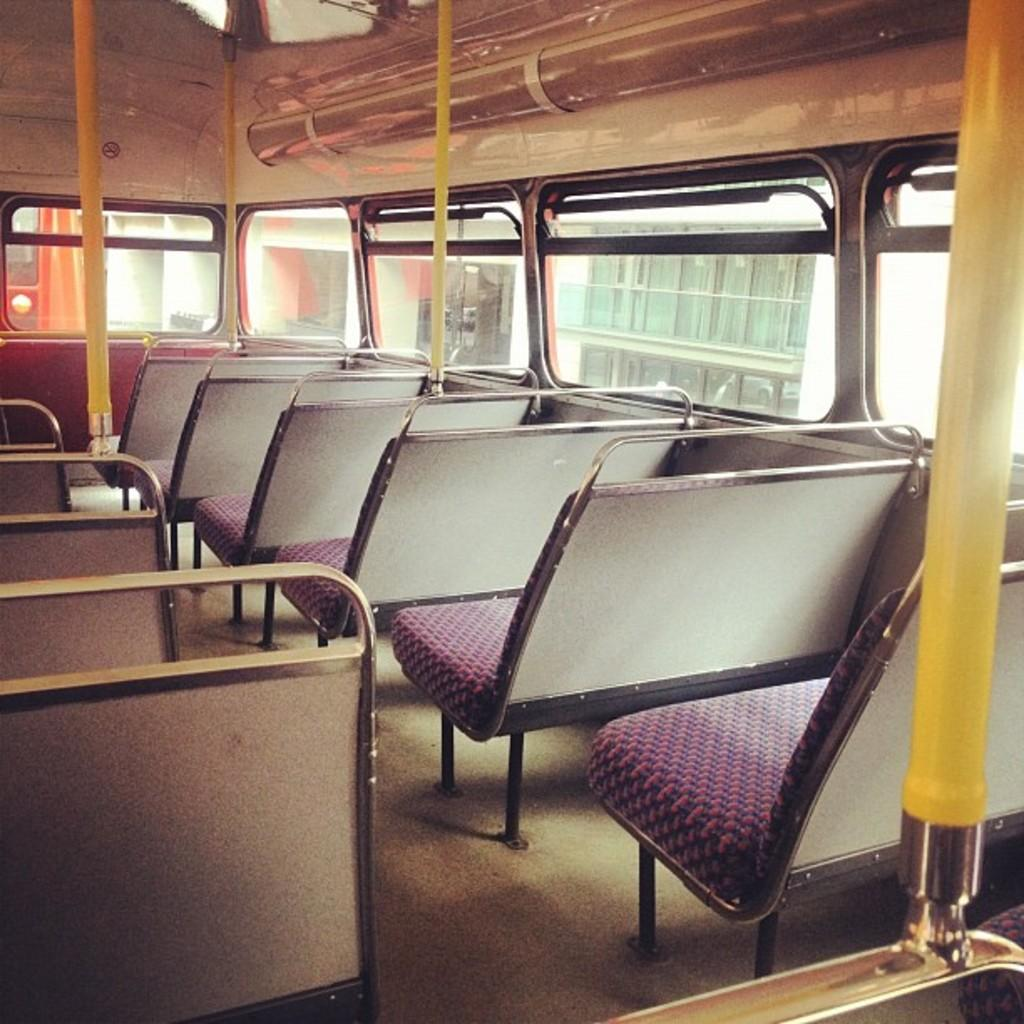Where was the image taken? The image was taken inside a bus. What can be found inside the bus? There are many seats inside the bus. What type of windows are in the bus? There are glass windows in the bus. What is visible outside the bus through the windows? There is a building visible outside through the windows. How many kittens can be seen playing with things in the image? There are no kittens present in the image. What is the bus dropping off at the building outside? The image does not show the bus dropping off anything at the building outside. 